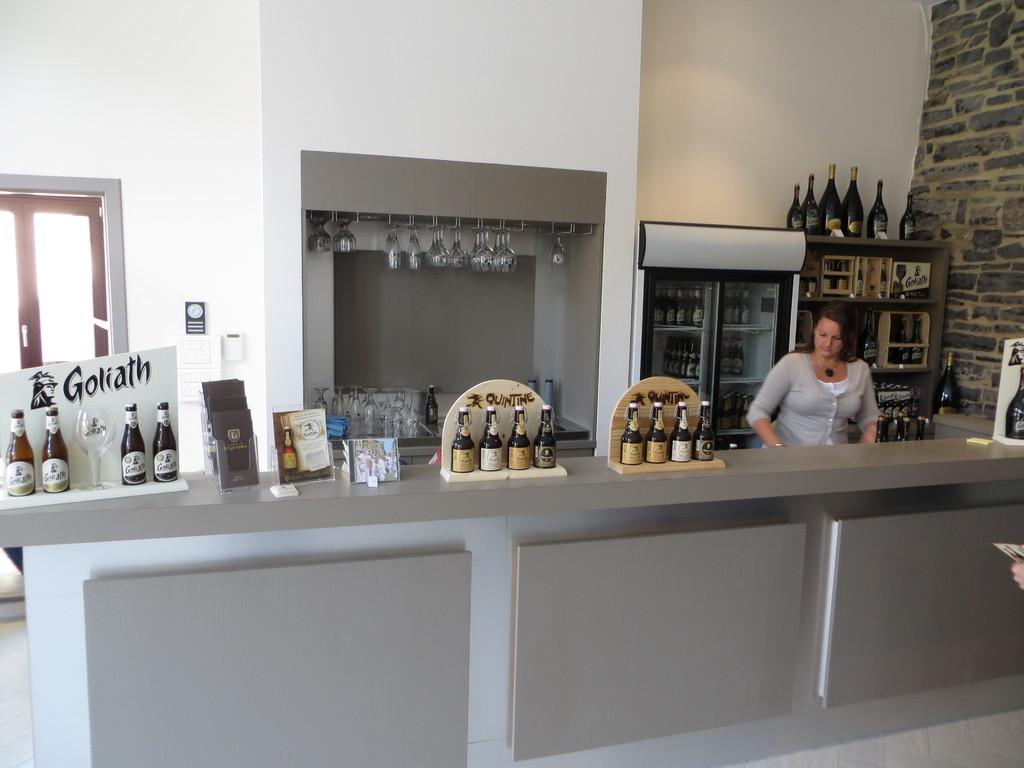What type of containers are present in the image? There are bottles in the image. What type of glasses are present in the image? There are wine glasses in the image. Who is present in the image? There is a woman standing in the image. What type of question is the woman asking in the image? There is no indication in the image that the woman is asking a question. 